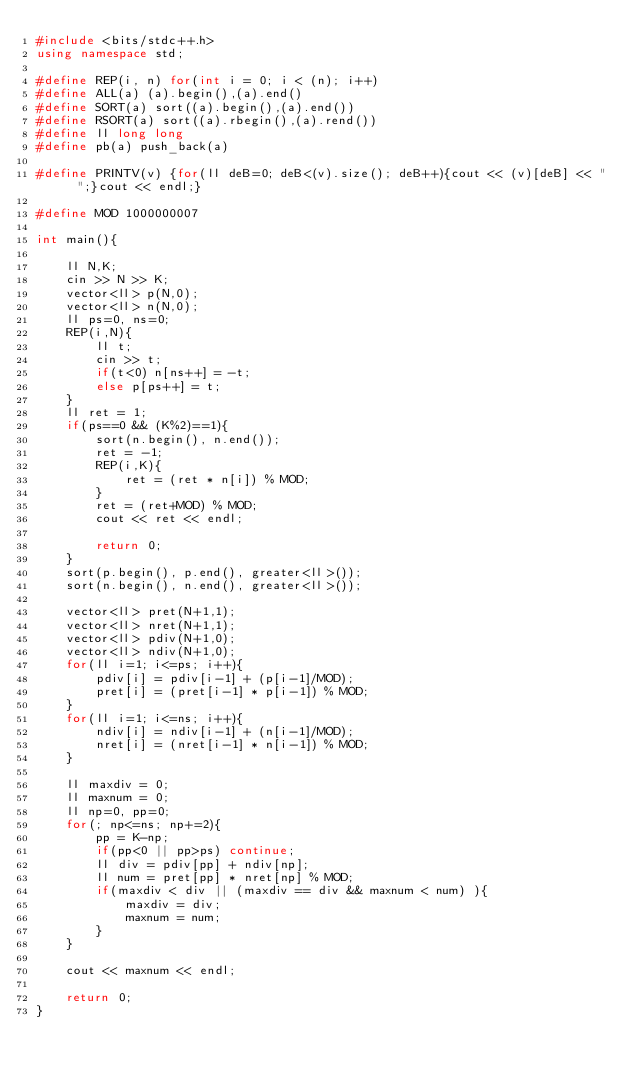Convert code to text. <code><loc_0><loc_0><loc_500><loc_500><_C++_>#include <bits/stdc++.h>
using namespace std;

#define REP(i, n) for(int i = 0; i < (n); i++)
#define ALL(a) (a).begin(),(a).end()
#define SORT(a) sort((a).begin(),(a).end())
#define RSORT(a) sort((a).rbegin(),(a).rend())
#define ll long long
#define pb(a) push_back(a)

#define PRINTV(v) {for(ll deB=0; deB<(v).size(); deB++){cout << (v)[deB] << " ";}cout << endl;}

#define MOD 1000000007

int main(){
	
	ll N,K;
	cin >> N >> K;
	vector<ll> p(N,0);
	vector<ll> n(N,0);
	ll ps=0, ns=0;
	REP(i,N){
		ll t;
		cin >> t;
		if(t<0) n[ns++] = -t;
		else p[ps++] = t;
	}
	ll ret = 1;
	if(ps==0 && (K%2)==1){
		sort(n.begin(), n.end());
		ret = -1;
		REP(i,K){
			ret = (ret * n[i]) % MOD;
		}
		ret = (ret+MOD) % MOD;
		cout << ret << endl;
		
		return 0;
	}
	sort(p.begin(), p.end(), greater<ll>());
	sort(n.begin(), n.end(), greater<ll>());

	vector<ll> pret(N+1,1);
	vector<ll> nret(N+1,1);
	vector<ll> pdiv(N+1,0);
	vector<ll> ndiv(N+1,0);
	for(ll i=1; i<=ps; i++){
		pdiv[i] = pdiv[i-1] + (p[i-1]/MOD);
		pret[i] = (pret[i-1] * p[i-1]) % MOD;
	}
	for(ll i=1; i<=ns; i++){
		ndiv[i] = ndiv[i-1] + (n[i-1]/MOD);
		nret[i] = (nret[i-1] * n[i-1]) % MOD;
	}

	ll maxdiv = 0;
	ll maxnum = 0;
	ll np=0, pp=0;
	for(; np<=ns; np+=2){
		pp = K-np;
		if(pp<0 || pp>ps) continue;
		ll div = pdiv[pp] + ndiv[np];
		ll num = pret[pp] * nret[np] % MOD;
		if(maxdiv < div || (maxdiv == div && maxnum < num) ){
			maxdiv = div;
			maxnum = num;
		}
	}
	
	cout << maxnum << endl;
	
	return 0;
}</code> 